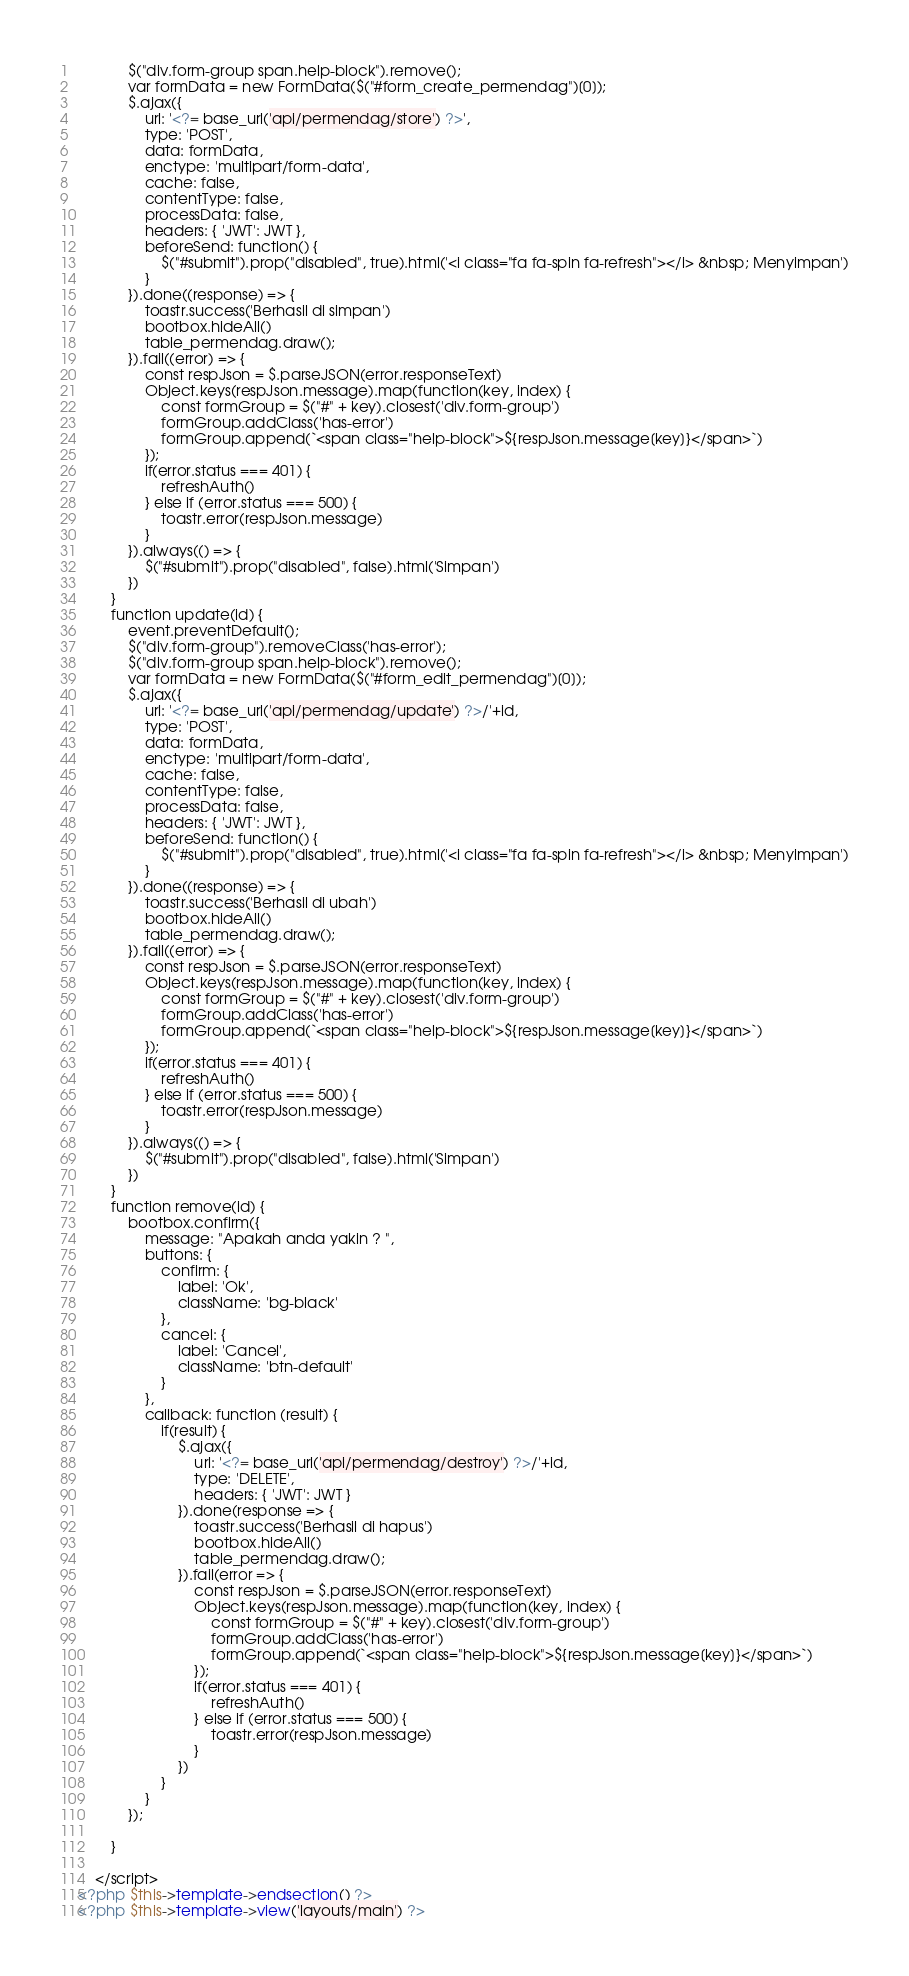<code> <loc_0><loc_0><loc_500><loc_500><_PHP_>            $("div.form-group span.help-block").remove();
            var formData = new FormData($("#form_create_permendag")[0]);
            $.ajax({
                url: '<?= base_url('api/permendag/store') ?>',
                type: 'POST',
                data: formData,
                enctype: 'multipart/form-data',
                cache: false,
                contentType: false,
                processData: false,
                headers: { 'JWT': JWT },
                beforeSend: function() {
                    $("#submit").prop("disabled", true).html('<i class="fa fa-spin fa-refresh"></i> &nbsp; Menyimpan')
                }
            }).done((response) => {
                toastr.success('Berhasil di simpan')
                bootbox.hideAll()
                table_permendag.draw();
            }).fail((error) => {
                const respJson = $.parseJSON(error.responseText)
                Object.keys(respJson.message).map(function(key, index) {
                    const formGroup = $("#" + key).closest('div.form-group')
                    formGroup.addClass('has-error')
                    formGroup.append(`<span class="help-block">${respJson.message[key]}</span>`)
                });
                if(error.status === 401) {
                    refreshAuth()
                } else if (error.status === 500) {
                    toastr.error(respJson.message)
                }
            }).always(() => {
                $("#submit").prop("disabled", false).html('Simpan')
            })
        }
        function update(id) {
            event.preventDefault();    
            $("div.form-group").removeClass('has-error');
            $("div.form-group span.help-block").remove();
            var formData = new FormData($("#form_edit_permendag")[0]);
            $.ajax({
                url: '<?= base_url('api/permendag/update') ?>/'+id,
                type: 'POST',
                data: formData,
                enctype: 'multipart/form-data',
                cache: false,
                contentType: false,
                processData: false,
                headers: { 'JWT': JWT },
                beforeSend: function() {
                    $("#submit").prop("disabled", true).html('<i class="fa fa-spin fa-refresh"></i> &nbsp; Menyimpan')
                }
            }).done((response) => {
                toastr.success('Berhasil di ubah')
                bootbox.hideAll()
                table_permendag.draw();
            }).fail((error) => {
                const respJson = $.parseJSON(error.responseText)
                Object.keys(respJson.message).map(function(key, index) {
                    const formGroup = $("#" + key).closest('div.form-group')
                    formGroup.addClass('has-error')
                    formGroup.append(`<span class="help-block">${respJson.message[key]}</span>`)
                });
                if(error.status === 401) {
                    refreshAuth()
                } else if (error.status === 500) {
                    toastr.error(respJson.message)
                }
            }).always(() => {
                $("#submit").prop("disabled", false).html('Simpan')
            })
        }
        function remove(id) {
            bootbox.confirm({
                message: "Apakah anda yakin ? ",
                buttons: {
                    confirm: {
                        label: 'Ok',
                        className: 'bg-black'
                    },
                    cancel: {
                        label: 'Cancel',
                        className: 'btn-default'
                    }
                },
                callback: function (result) {
                    if(result) {
                        $.ajax({
                            url: '<?= base_url('api/permendag/destroy') ?>/'+id,
                            type: 'DELETE',
                            headers: { 'JWT': JWT }
                        }).done(response => {
                            toastr.success('Berhasil di hapus')
                            bootbox.hideAll()
                            table_permendag.draw();
                        }).fail(error => {
                            const respJson = $.parseJSON(error.responseText)
                            Object.keys(respJson.message).map(function(key, index) {
                                const formGroup = $("#" + key).closest('div.form-group')
                                formGroup.addClass('has-error')
                                formGroup.append(`<span class="help-block">${respJson.message[key]}</span>`)
                            });
                            if(error.status === 401) {
                                refreshAuth()
                            } else if (error.status === 500) {
                                toastr.error(respJson.message)
                            }
                        })
                    }
                }
            });
            
        }
        
    </script>
<?php $this->template->endsection() ?>
<?php $this->template->view('layouts/main') ?>
</code> 